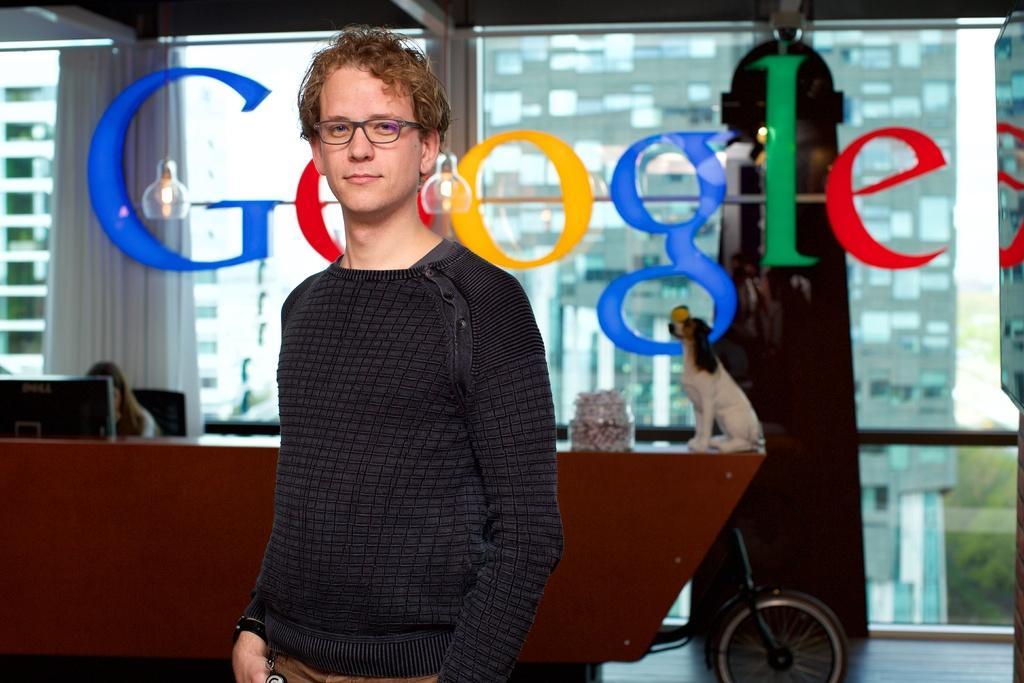Please provide a concise description of this image. There is a man standing and wore spectacle. In the background we can see dog and object on the table. There is a person sitting,in front of this person we can see monitor and we can see glass,through this glass we can see building and we can see name on this glass. 